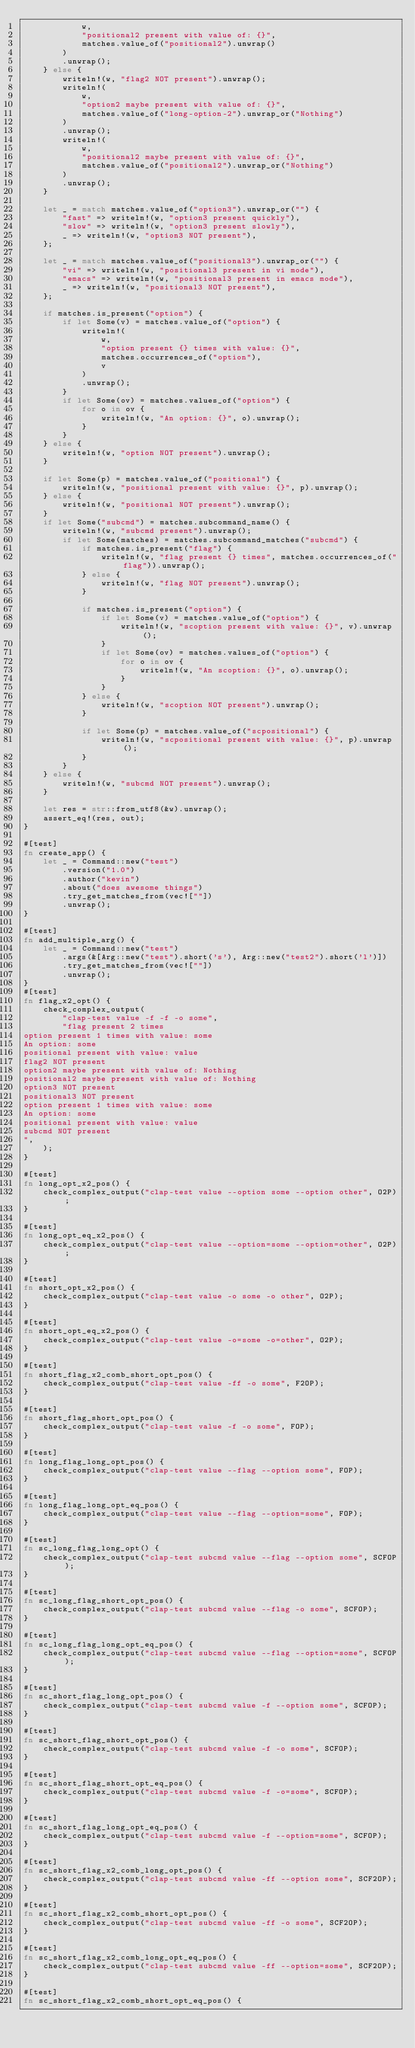<code> <loc_0><loc_0><loc_500><loc_500><_Rust_>            w,
            "positional2 present with value of: {}",
            matches.value_of("positional2").unwrap()
        )
        .unwrap();
    } else {
        writeln!(w, "flag2 NOT present").unwrap();
        writeln!(
            w,
            "option2 maybe present with value of: {}",
            matches.value_of("long-option-2").unwrap_or("Nothing")
        )
        .unwrap();
        writeln!(
            w,
            "positional2 maybe present with value of: {}",
            matches.value_of("positional2").unwrap_or("Nothing")
        )
        .unwrap();
    }

    let _ = match matches.value_of("option3").unwrap_or("") {
        "fast" => writeln!(w, "option3 present quickly"),
        "slow" => writeln!(w, "option3 present slowly"),
        _ => writeln!(w, "option3 NOT present"),
    };

    let _ = match matches.value_of("positional3").unwrap_or("") {
        "vi" => writeln!(w, "positional3 present in vi mode"),
        "emacs" => writeln!(w, "positional3 present in emacs mode"),
        _ => writeln!(w, "positional3 NOT present"),
    };

    if matches.is_present("option") {
        if let Some(v) = matches.value_of("option") {
            writeln!(
                w,
                "option present {} times with value: {}",
                matches.occurrences_of("option"),
                v
            )
            .unwrap();
        }
        if let Some(ov) = matches.values_of("option") {
            for o in ov {
                writeln!(w, "An option: {}", o).unwrap();
            }
        }
    } else {
        writeln!(w, "option NOT present").unwrap();
    }

    if let Some(p) = matches.value_of("positional") {
        writeln!(w, "positional present with value: {}", p).unwrap();
    } else {
        writeln!(w, "positional NOT present").unwrap();
    }
    if let Some("subcmd") = matches.subcommand_name() {
        writeln!(w, "subcmd present").unwrap();
        if let Some(matches) = matches.subcommand_matches("subcmd") {
            if matches.is_present("flag") {
                writeln!(w, "flag present {} times", matches.occurrences_of("flag")).unwrap();
            } else {
                writeln!(w, "flag NOT present").unwrap();
            }

            if matches.is_present("option") {
                if let Some(v) = matches.value_of("option") {
                    writeln!(w, "scoption present with value: {}", v).unwrap();
                }
                if let Some(ov) = matches.values_of("option") {
                    for o in ov {
                        writeln!(w, "An scoption: {}", o).unwrap();
                    }
                }
            } else {
                writeln!(w, "scoption NOT present").unwrap();
            }

            if let Some(p) = matches.value_of("scpositional") {
                writeln!(w, "scpositional present with value: {}", p).unwrap();
            }
        }
    } else {
        writeln!(w, "subcmd NOT present").unwrap();
    }

    let res = str::from_utf8(&w).unwrap();
    assert_eq!(res, out);
}

#[test]
fn create_app() {
    let _ = Command::new("test")
        .version("1.0")
        .author("kevin")
        .about("does awesome things")
        .try_get_matches_from(vec![""])
        .unwrap();
}

#[test]
fn add_multiple_arg() {
    let _ = Command::new("test")
        .args(&[Arg::new("test").short('s'), Arg::new("test2").short('l')])
        .try_get_matches_from(vec![""])
        .unwrap();
}
#[test]
fn flag_x2_opt() {
    check_complex_output(
        "clap-test value -f -f -o some",
        "flag present 2 times
option present 1 times with value: some
An option: some
positional present with value: value
flag2 NOT present
option2 maybe present with value of: Nothing
positional2 maybe present with value of: Nothing
option3 NOT present
positional3 NOT present
option present 1 times with value: some
An option: some
positional present with value: value
subcmd NOT present
",
    );
}

#[test]
fn long_opt_x2_pos() {
    check_complex_output("clap-test value --option some --option other", O2P);
}

#[test]
fn long_opt_eq_x2_pos() {
    check_complex_output("clap-test value --option=some --option=other", O2P);
}

#[test]
fn short_opt_x2_pos() {
    check_complex_output("clap-test value -o some -o other", O2P);
}

#[test]
fn short_opt_eq_x2_pos() {
    check_complex_output("clap-test value -o=some -o=other", O2P);
}

#[test]
fn short_flag_x2_comb_short_opt_pos() {
    check_complex_output("clap-test value -ff -o some", F2OP);
}

#[test]
fn short_flag_short_opt_pos() {
    check_complex_output("clap-test value -f -o some", FOP);
}

#[test]
fn long_flag_long_opt_pos() {
    check_complex_output("clap-test value --flag --option some", FOP);
}

#[test]
fn long_flag_long_opt_eq_pos() {
    check_complex_output("clap-test value --flag --option=some", FOP);
}

#[test]
fn sc_long_flag_long_opt() {
    check_complex_output("clap-test subcmd value --flag --option some", SCFOP);
}

#[test]
fn sc_long_flag_short_opt_pos() {
    check_complex_output("clap-test subcmd value --flag -o some", SCFOP);
}

#[test]
fn sc_long_flag_long_opt_eq_pos() {
    check_complex_output("clap-test subcmd value --flag --option=some", SCFOP);
}

#[test]
fn sc_short_flag_long_opt_pos() {
    check_complex_output("clap-test subcmd value -f --option some", SCFOP);
}

#[test]
fn sc_short_flag_short_opt_pos() {
    check_complex_output("clap-test subcmd value -f -o some", SCFOP);
}

#[test]
fn sc_short_flag_short_opt_eq_pos() {
    check_complex_output("clap-test subcmd value -f -o=some", SCFOP);
}

#[test]
fn sc_short_flag_long_opt_eq_pos() {
    check_complex_output("clap-test subcmd value -f --option=some", SCFOP);
}

#[test]
fn sc_short_flag_x2_comb_long_opt_pos() {
    check_complex_output("clap-test subcmd value -ff --option some", SCF2OP);
}

#[test]
fn sc_short_flag_x2_comb_short_opt_pos() {
    check_complex_output("clap-test subcmd value -ff -o some", SCF2OP);
}

#[test]
fn sc_short_flag_x2_comb_long_opt_eq_pos() {
    check_complex_output("clap-test subcmd value -ff --option=some", SCF2OP);
}

#[test]
fn sc_short_flag_x2_comb_short_opt_eq_pos() {</code> 